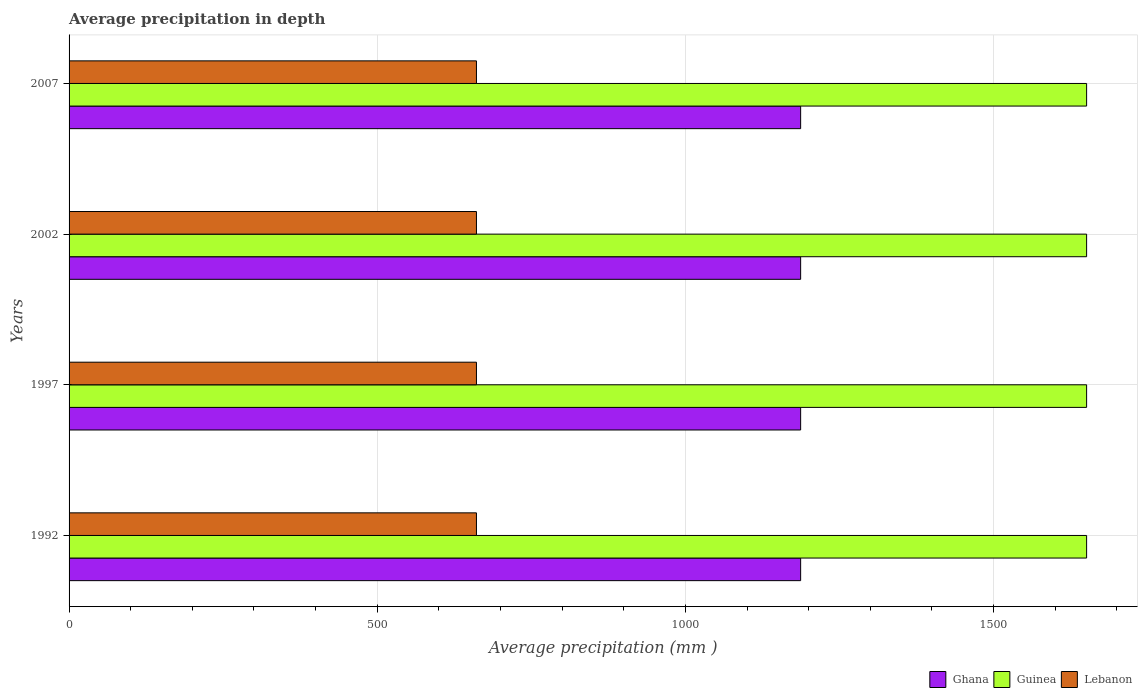Are the number of bars per tick equal to the number of legend labels?
Make the answer very short. Yes. Are the number of bars on each tick of the Y-axis equal?
Your response must be concise. Yes. How many bars are there on the 3rd tick from the top?
Your answer should be compact. 3. What is the label of the 1st group of bars from the top?
Make the answer very short. 2007. In how many cases, is the number of bars for a given year not equal to the number of legend labels?
Keep it short and to the point. 0. What is the average precipitation in Ghana in 2002?
Ensure brevity in your answer.  1187. Across all years, what is the maximum average precipitation in Lebanon?
Offer a very short reply. 661. Across all years, what is the minimum average precipitation in Guinea?
Provide a short and direct response. 1651. In which year was the average precipitation in Lebanon maximum?
Offer a terse response. 1992. What is the total average precipitation in Guinea in the graph?
Offer a very short reply. 6604. What is the difference between the average precipitation in Ghana in 1992 and the average precipitation in Guinea in 2002?
Your answer should be very brief. -464. What is the average average precipitation in Ghana per year?
Provide a succinct answer. 1187. In the year 2007, what is the difference between the average precipitation in Ghana and average precipitation in Lebanon?
Keep it short and to the point. 526. In how many years, is the average precipitation in Ghana greater than 200 mm?
Provide a short and direct response. 4. What is the ratio of the average precipitation in Guinea in 1997 to that in 2007?
Give a very brief answer. 1. Is the difference between the average precipitation in Ghana in 1997 and 2002 greater than the difference between the average precipitation in Lebanon in 1997 and 2002?
Offer a terse response. No. What is the difference between the highest and the second highest average precipitation in Guinea?
Your answer should be very brief. 0. Is the sum of the average precipitation in Guinea in 1992 and 1997 greater than the maximum average precipitation in Lebanon across all years?
Offer a terse response. Yes. What does the 1st bar from the top in 2007 represents?
Make the answer very short. Lebanon. What does the 3rd bar from the bottom in 2002 represents?
Ensure brevity in your answer.  Lebanon. Is it the case that in every year, the sum of the average precipitation in Guinea and average precipitation in Ghana is greater than the average precipitation in Lebanon?
Offer a very short reply. Yes. How many years are there in the graph?
Your answer should be very brief. 4. Are the values on the major ticks of X-axis written in scientific E-notation?
Make the answer very short. No. How many legend labels are there?
Provide a succinct answer. 3. What is the title of the graph?
Keep it short and to the point. Average precipitation in depth. What is the label or title of the X-axis?
Provide a succinct answer. Average precipitation (mm ). What is the Average precipitation (mm ) in Ghana in 1992?
Offer a terse response. 1187. What is the Average precipitation (mm ) of Guinea in 1992?
Your response must be concise. 1651. What is the Average precipitation (mm ) of Lebanon in 1992?
Your answer should be very brief. 661. What is the Average precipitation (mm ) of Ghana in 1997?
Offer a very short reply. 1187. What is the Average precipitation (mm ) of Guinea in 1997?
Offer a very short reply. 1651. What is the Average precipitation (mm ) in Lebanon in 1997?
Your answer should be very brief. 661. What is the Average precipitation (mm ) of Ghana in 2002?
Ensure brevity in your answer.  1187. What is the Average precipitation (mm ) of Guinea in 2002?
Your answer should be compact. 1651. What is the Average precipitation (mm ) of Lebanon in 2002?
Offer a very short reply. 661. What is the Average precipitation (mm ) in Ghana in 2007?
Give a very brief answer. 1187. What is the Average precipitation (mm ) of Guinea in 2007?
Offer a very short reply. 1651. What is the Average precipitation (mm ) of Lebanon in 2007?
Offer a terse response. 661. Across all years, what is the maximum Average precipitation (mm ) in Ghana?
Provide a short and direct response. 1187. Across all years, what is the maximum Average precipitation (mm ) in Guinea?
Offer a very short reply. 1651. Across all years, what is the maximum Average precipitation (mm ) in Lebanon?
Keep it short and to the point. 661. Across all years, what is the minimum Average precipitation (mm ) of Ghana?
Give a very brief answer. 1187. Across all years, what is the minimum Average precipitation (mm ) of Guinea?
Keep it short and to the point. 1651. Across all years, what is the minimum Average precipitation (mm ) in Lebanon?
Keep it short and to the point. 661. What is the total Average precipitation (mm ) of Ghana in the graph?
Keep it short and to the point. 4748. What is the total Average precipitation (mm ) of Guinea in the graph?
Your answer should be compact. 6604. What is the total Average precipitation (mm ) in Lebanon in the graph?
Provide a succinct answer. 2644. What is the difference between the Average precipitation (mm ) in Guinea in 1992 and that in 2002?
Give a very brief answer. 0. What is the difference between the Average precipitation (mm ) of Guinea in 1992 and that in 2007?
Your response must be concise. 0. What is the difference between the Average precipitation (mm ) in Lebanon in 1992 and that in 2007?
Provide a short and direct response. 0. What is the difference between the Average precipitation (mm ) of Ghana in 1997 and that in 2002?
Make the answer very short. 0. What is the difference between the Average precipitation (mm ) of Guinea in 1997 and that in 2002?
Ensure brevity in your answer.  0. What is the difference between the Average precipitation (mm ) of Ghana in 1997 and that in 2007?
Provide a short and direct response. 0. What is the difference between the Average precipitation (mm ) in Guinea in 1997 and that in 2007?
Offer a terse response. 0. What is the difference between the Average precipitation (mm ) in Ghana in 2002 and that in 2007?
Your response must be concise. 0. What is the difference between the Average precipitation (mm ) of Guinea in 2002 and that in 2007?
Offer a very short reply. 0. What is the difference between the Average precipitation (mm ) in Ghana in 1992 and the Average precipitation (mm ) in Guinea in 1997?
Provide a short and direct response. -464. What is the difference between the Average precipitation (mm ) of Ghana in 1992 and the Average precipitation (mm ) of Lebanon in 1997?
Your answer should be very brief. 526. What is the difference between the Average precipitation (mm ) in Guinea in 1992 and the Average precipitation (mm ) in Lebanon in 1997?
Offer a terse response. 990. What is the difference between the Average precipitation (mm ) of Ghana in 1992 and the Average precipitation (mm ) of Guinea in 2002?
Offer a terse response. -464. What is the difference between the Average precipitation (mm ) in Ghana in 1992 and the Average precipitation (mm ) in Lebanon in 2002?
Make the answer very short. 526. What is the difference between the Average precipitation (mm ) of Guinea in 1992 and the Average precipitation (mm ) of Lebanon in 2002?
Keep it short and to the point. 990. What is the difference between the Average precipitation (mm ) in Ghana in 1992 and the Average precipitation (mm ) in Guinea in 2007?
Provide a succinct answer. -464. What is the difference between the Average precipitation (mm ) of Ghana in 1992 and the Average precipitation (mm ) of Lebanon in 2007?
Provide a short and direct response. 526. What is the difference between the Average precipitation (mm ) in Guinea in 1992 and the Average precipitation (mm ) in Lebanon in 2007?
Keep it short and to the point. 990. What is the difference between the Average precipitation (mm ) of Ghana in 1997 and the Average precipitation (mm ) of Guinea in 2002?
Offer a very short reply. -464. What is the difference between the Average precipitation (mm ) of Ghana in 1997 and the Average precipitation (mm ) of Lebanon in 2002?
Your answer should be very brief. 526. What is the difference between the Average precipitation (mm ) in Guinea in 1997 and the Average precipitation (mm ) in Lebanon in 2002?
Ensure brevity in your answer.  990. What is the difference between the Average precipitation (mm ) of Ghana in 1997 and the Average precipitation (mm ) of Guinea in 2007?
Provide a succinct answer. -464. What is the difference between the Average precipitation (mm ) of Ghana in 1997 and the Average precipitation (mm ) of Lebanon in 2007?
Your answer should be compact. 526. What is the difference between the Average precipitation (mm ) of Guinea in 1997 and the Average precipitation (mm ) of Lebanon in 2007?
Your response must be concise. 990. What is the difference between the Average precipitation (mm ) of Ghana in 2002 and the Average precipitation (mm ) of Guinea in 2007?
Make the answer very short. -464. What is the difference between the Average precipitation (mm ) of Ghana in 2002 and the Average precipitation (mm ) of Lebanon in 2007?
Offer a terse response. 526. What is the difference between the Average precipitation (mm ) of Guinea in 2002 and the Average precipitation (mm ) of Lebanon in 2007?
Provide a succinct answer. 990. What is the average Average precipitation (mm ) of Ghana per year?
Your answer should be very brief. 1187. What is the average Average precipitation (mm ) of Guinea per year?
Your response must be concise. 1651. What is the average Average precipitation (mm ) in Lebanon per year?
Make the answer very short. 661. In the year 1992, what is the difference between the Average precipitation (mm ) in Ghana and Average precipitation (mm ) in Guinea?
Offer a very short reply. -464. In the year 1992, what is the difference between the Average precipitation (mm ) in Ghana and Average precipitation (mm ) in Lebanon?
Your answer should be very brief. 526. In the year 1992, what is the difference between the Average precipitation (mm ) in Guinea and Average precipitation (mm ) in Lebanon?
Keep it short and to the point. 990. In the year 1997, what is the difference between the Average precipitation (mm ) in Ghana and Average precipitation (mm ) in Guinea?
Your answer should be compact. -464. In the year 1997, what is the difference between the Average precipitation (mm ) of Ghana and Average precipitation (mm ) of Lebanon?
Your answer should be compact. 526. In the year 1997, what is the difference between the Average precipitation (mm ) in Guinea and Average precipitation (mm ) in Lebanon?
Offer a terse response. 990. In the year 2002, what is the difference between the Average precipitation (mm ) of Ghana and Average precipitation (mm ) of Guinea?
Ensure brevity in your answer.  -464. In the year 2002, what is the difference between the Average precipitation (mm ) of Ghana and Average precipitation (mm ) of Lebanon?
Offer a terse response. 526. In the year 2002, what is the difference between the Average precipitation (mm ) of Guinea and Average precipitation (mm ) of Lebanon?
Your answer should be compact. 990. In the year 2007, what is the difference between the Average precipitation (mm ) of Ghana and Average precipitation (mm ) of Guinea?
Offer a very short reply. -464. In the year 2007, what is the difference between the Average precipitation (mm ) of Ghana and Average precipitation (mm ) of Lebanon?
Give a very brief answer. 526. In the year 2007, what is the difference between the Average precipitation (mm ) of Guinea and Average precipitation (mm ) of Lebanon?
Provide a short and direct response. 990. What is the ratio of the Average precipitation (mm ) in Ghana in 1992 to that in 1997?
Make the answer very short. 1. What is the ratio of the Average precipitation (mm ) of Lebanon in 1992 to that in 1997?
Offer a terse response. 1. What is the ratio of the Average precipitation (mm ) of Ghana in 1992 to that in 2002?
Offer a very short reply. 1. What is the ratio of the Average precipitation (mm ) of Guinea in 1992 to that in 2002?
Provide a succinct answer. 1. What is the ratio of the Average precipitation (mm ) of Ghana in 1992 to that in 2007?
Your response must be concise. 1. What is the ratio of the Average precipitation (mm ) of Guinea in 1992 to that in 2007?
Make the answer very short. 1. What is the ratio of the Average precipitation (mm ) in Ghana in 1997 to that in 2002?
Keep it short and to the point. 1. What is the ratio of the Average precipitation (mm ) of Lebanon in 1997 to that in 2002?
Offer a very short reply. 1. What is the ratio of the Average precipitation (mm ) of Guinea in 1997 to that in 2007?
Offer a terse response. 1. What is the ratio of the Average precipitation (mm ) of Lebanon in 1997 to that in 2007?
Offer a very short reply. 1. What is the ratio of the Average precipitation (mm ) in Guinea in 2002 to that in 2007?
Give a very brief answer. 1. What is the ratio of the Average precipitation (mm ) in Lebanon in 2002 to that in 2007?
Provide a short and direct response. 1. What is the difference between the highest and the second highest Average precipitation (mm ) in Guinea?
Offer a terse response. 0. What is the difference between the highest and the second highest Average precipitation (mm ) in Lebanon?
Provide a succinct answer. 0. What is the difference between the highest and the lowest Average precipitation (mm ) of Ghana?
Ensure brevity in your answer.  0. 